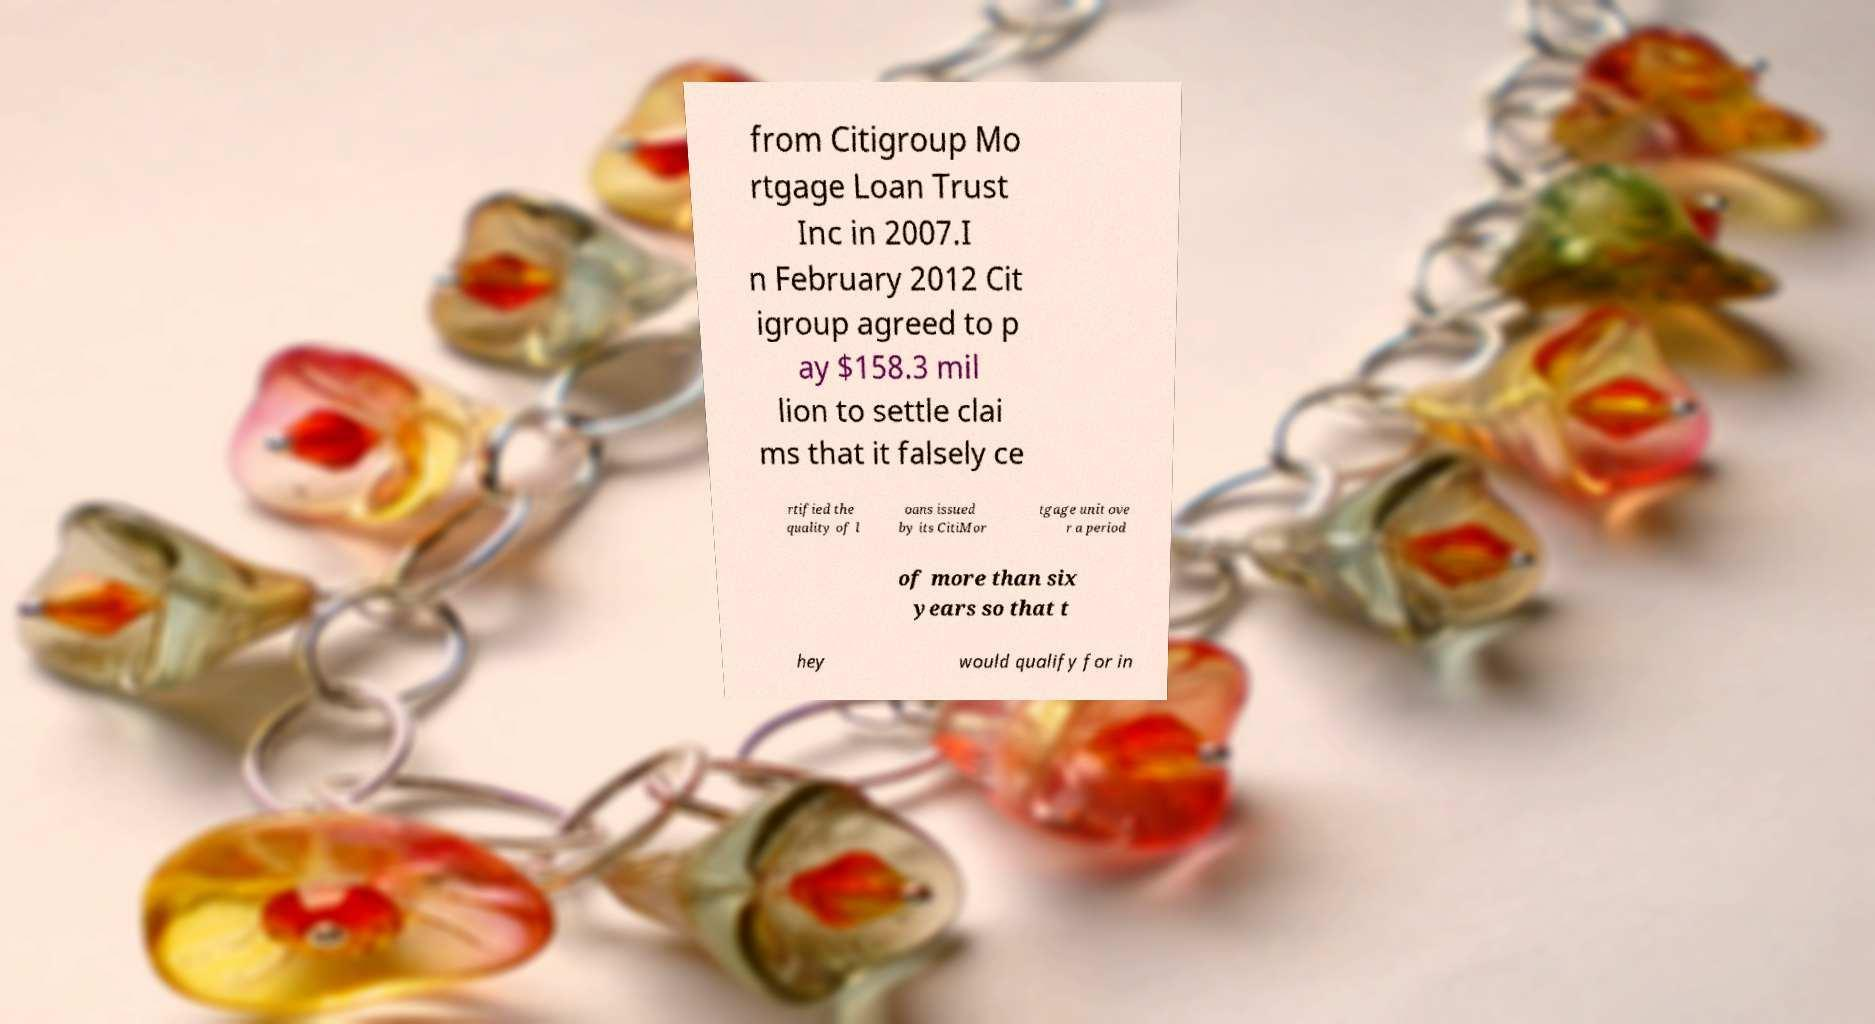Can you read and provide the text displayed in the image?This photo seems to have some interesting text. Can you extract and type it out for me? from Citigroup Mo rtgage Loan Trust Inc in 2007.I n February 2012 Cit igroup agreed to p ay $158.3 mil lion to settle clai ms that it falsely ce rtified the quality of l oans issued by its CitiMor tgage unit ove r a period of more than six years so that t hey would qualify for in 